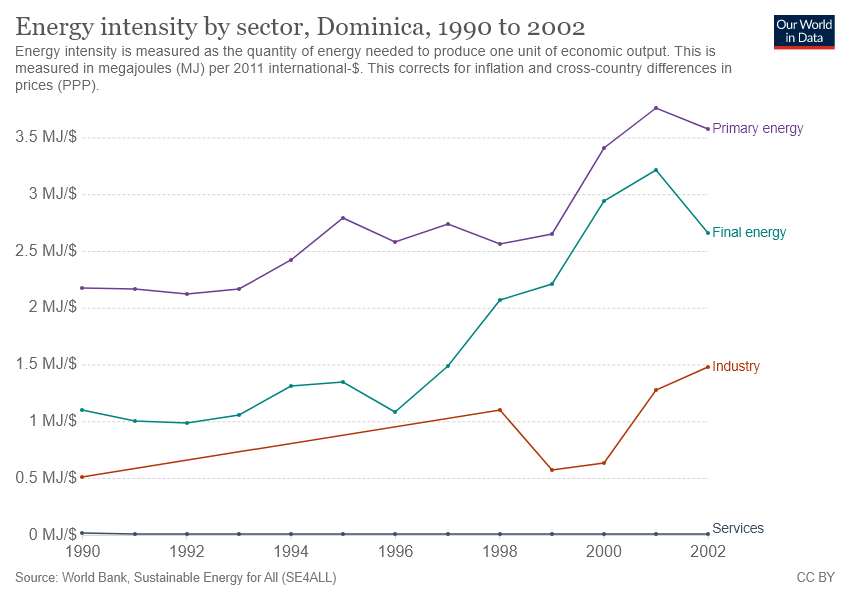Specify some key components in this picture. The Industry sector has the highest energy intensity in 2002. The sector with energy intensity between primary energy and industry is final energy. 